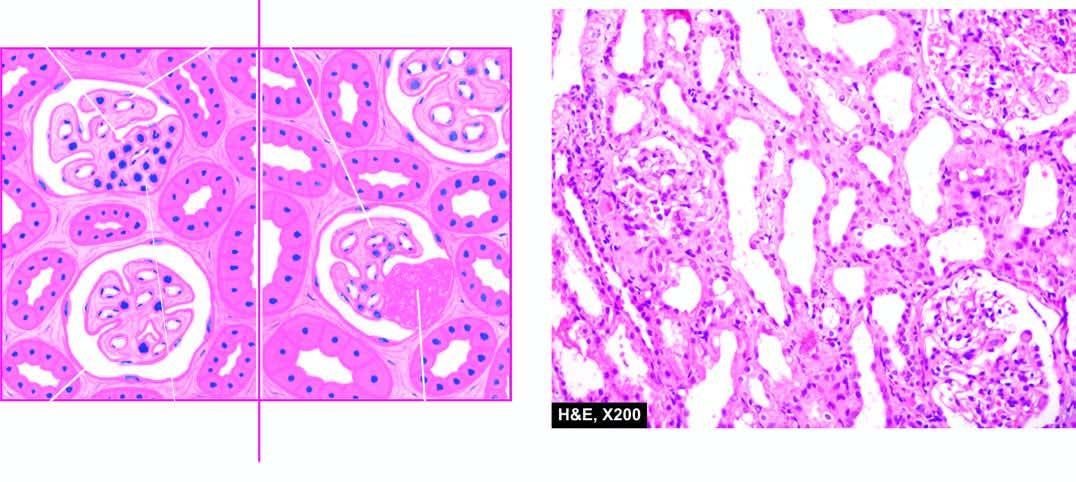s the characteristic feature the cellular proliferation in some glomeruli and in one or two lobules of the affected glomeruli ie?
Answer the question using a single word or phrase. Yes 